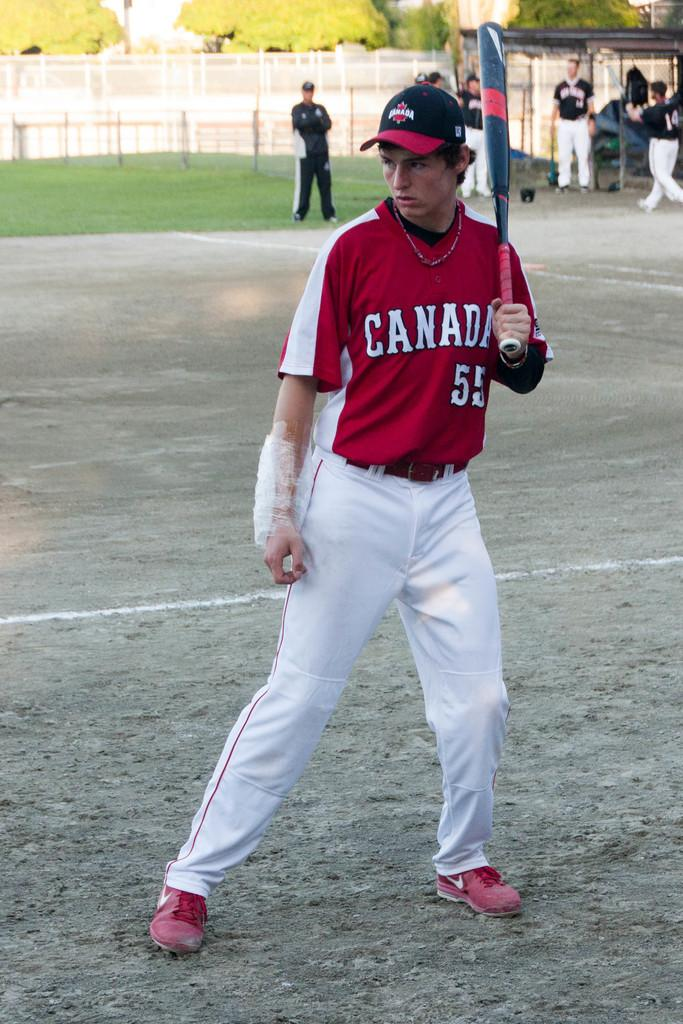<image>
Create a compact narrative representing the image presented. Canadian baseball player number fifty five with a bat in his right hand and a bag of ice attached to his left elbow. 